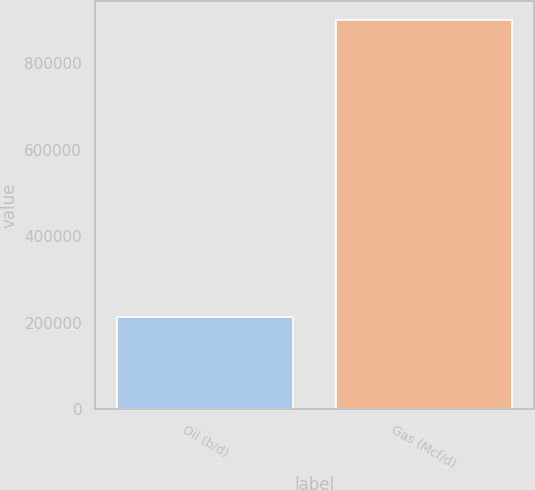Convert chart. <chart><loc_0><loc_0><loc_500><loc_500><bar_chart><fcel>Oil (b/d)<fcel>Gas (Mcf/d)<nl><fcel>213112<fcel>899972<nl></chart> 